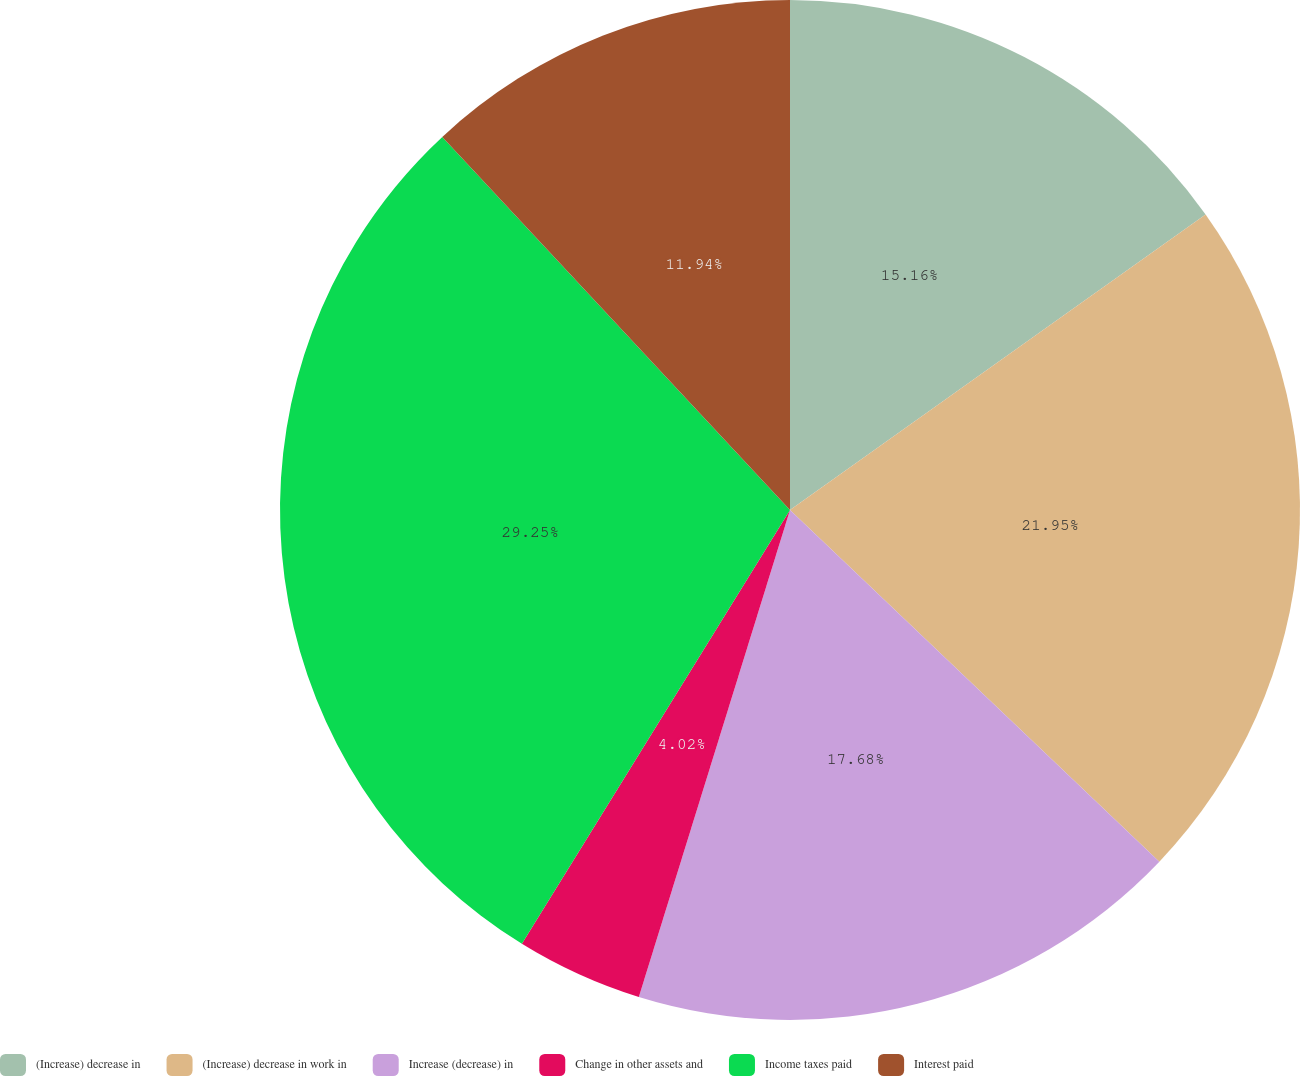<chart> <loc_0><loc_0><loc_500><loc_500><pie_chart><fcel>(Increase) decrease in<fcel>(Increase) decrease in work in<fcel>Increase (decrease) in<fcel>Change in other assets and<fcel>Income taxes paid<fcel>Interest paid<nl><fcel>15.16%<fcel>21.95%<fcel>17.68%<fcel>4.02%<fcel>29.25%<fcel>11.94%<nl></chart> 